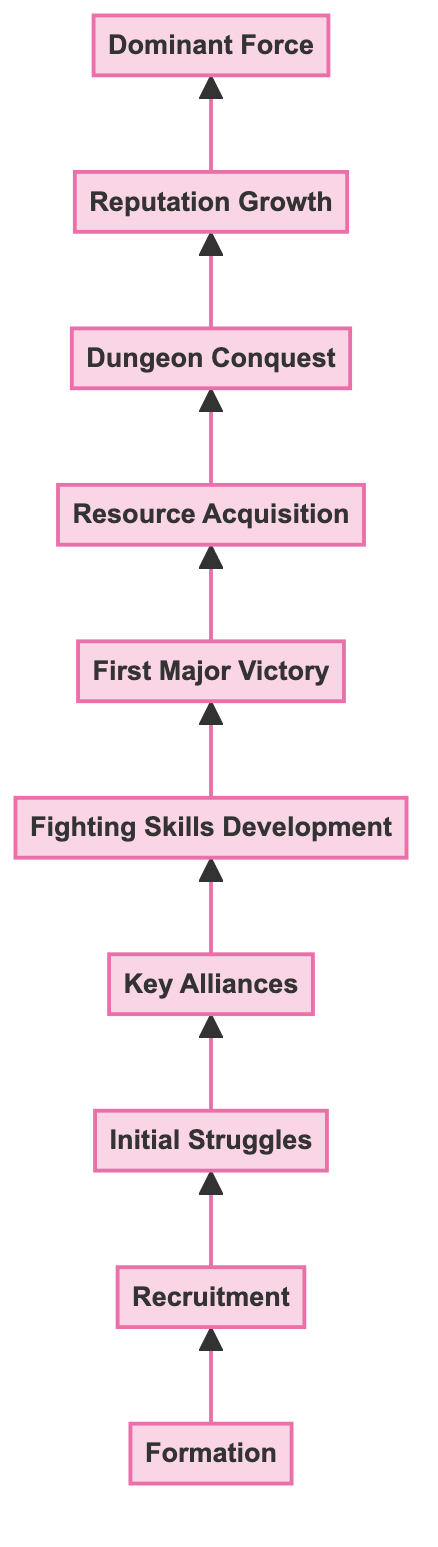What is the first step in the evolution of Hestia Familia? The diagram shows that the first step is "Formation," where Hestia Familia is founded by the Goddess Hestia and Bell Cranel.
Answer: Formation Which member was recruited after the Familia was formed? The diagram indicates that "Liliruca Arde" and "Welf Crozzo" are recruited after the formation, making them the first new members introduced in the flow.
Answer: Liliruca Arde and Welf Crozzo How many key stages are there from "Formation" to "Dominant Force"? By counting the nodes in the diagram, there are a total of 10 stages listed from "Formation" to "Dominant Force."
Answer: 10 What is the outcome of the "First Major Victory"? The diagram states that the first major victory was defeating the Minotaur on the 9th Floor, which earned Bell the title "Little Rookie."
Answer: Defeating the Minotaur What action follows "Resource Acquisition" in the chart? According to the flow of the diagram, "Dungeon Conquest" follows the stage of "Resource Acquisition," indicating the next step in the evolution of the Familia.
Answer: Dungeon Conquest What does Hestia Familia achieve as a "Dominant Force"? The diagram notes that as a dominant force, the Familia can influence events and protect its members, signifying their high status in Orario.
Answer: Influencing events and protecting members How does "Reputation Growth" relate to previous stages? "Reputation Growth" depends on the outcomes of "Dungeon Conquest" and "First Major Victory," as increasing fame and recognition likely stem from the successes achieved in those stages.
Answer: Depends on successes from earlier stages What is the main factor leading to "Key Alliances"? The diagram suggests that the initial struggles and challenges faced by the Familia necessitated the formation of "Key Alliances" with other Familias for better survival and support.
Answer: Initial struggles and challenges Which stage directly precedes the "Dominant Force"? Based on the diagram, "Reputation Growth" directly precedes the stage in which Hestia Familia becomes a "Dominant Force," highlighting the link between fame and power.
Answer: Reputation Growth 